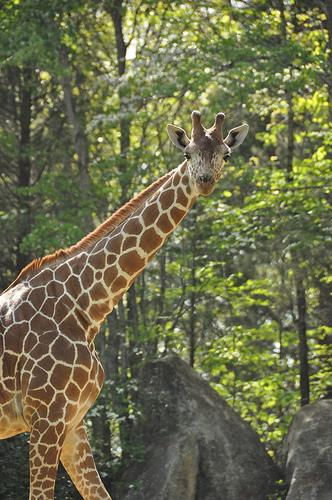What is the setting of the image and what other objects are present? The setting is a forest with green trees, big gray rocks, some large boulders and the sky peeking through the tree leaves. How many rocks are in the image and which are the predominant colors? There are 11 rocks in the image, predominantly gray and black. What can you notice about the giraffe's fur pattern and color? The giraffe has a beautiful pattern of white lines on its brown fur and large brown spots bounded by cream. Mention some notable features about the giraffe's position and pose. The giraffe's head is facing the camera, it has a long neck, two visible front legs and it's standing tall among rocks and trees. Describe the giraffe's neck and legs visible in the image. The giraffe has a long neck with a brown mane on its back, and two front visible legs. Identify some features of the giraffe's head and face. The giraffe's head has two short horns covered with fur, outstretched and erect ears, black nose, brown mouth, and eyes looking at the camera. Using three words, describe the overall atmosphere of the image. Nature, curiosity, serene. What's the giraffe's emotional appearance based on what you see? The giraffe appears curious and attentive, as it glances towards the camera with its ears perked up. What is the most prominent animal in the image and what is it doing? A giraffe standing tall and glancing towards the camera, with its head facing the camera. What's visible in the background of the image, and how does the light appear? Green trees are visible in the background with the sun shining through them and the sky visible a little through the tree leaves. Is the giraffe's fur plain brown without any pattern? The giraffe's fur is described as having a beautiful pattern of white lines on brown, not plain brown. Do the giraffe's horns have no fur on them? The horns are described as being covered with fur, not without it. Are the boulders in the image small and white? The boulders are described as being big and black or gray, not small and white. Is the giraffe's nose white and its mouth blue? The nose and mouth should be described as black and brown respectively, not white and blue. Can you see the entire sky with no obstruction from the tree leaves? The sky is described as being visible only a little through the tree leaves, not fully visible without obstruction. Are the trees in the background not part of a forest but rather a desert? The trees are described as being part of a forest, not a desert. 